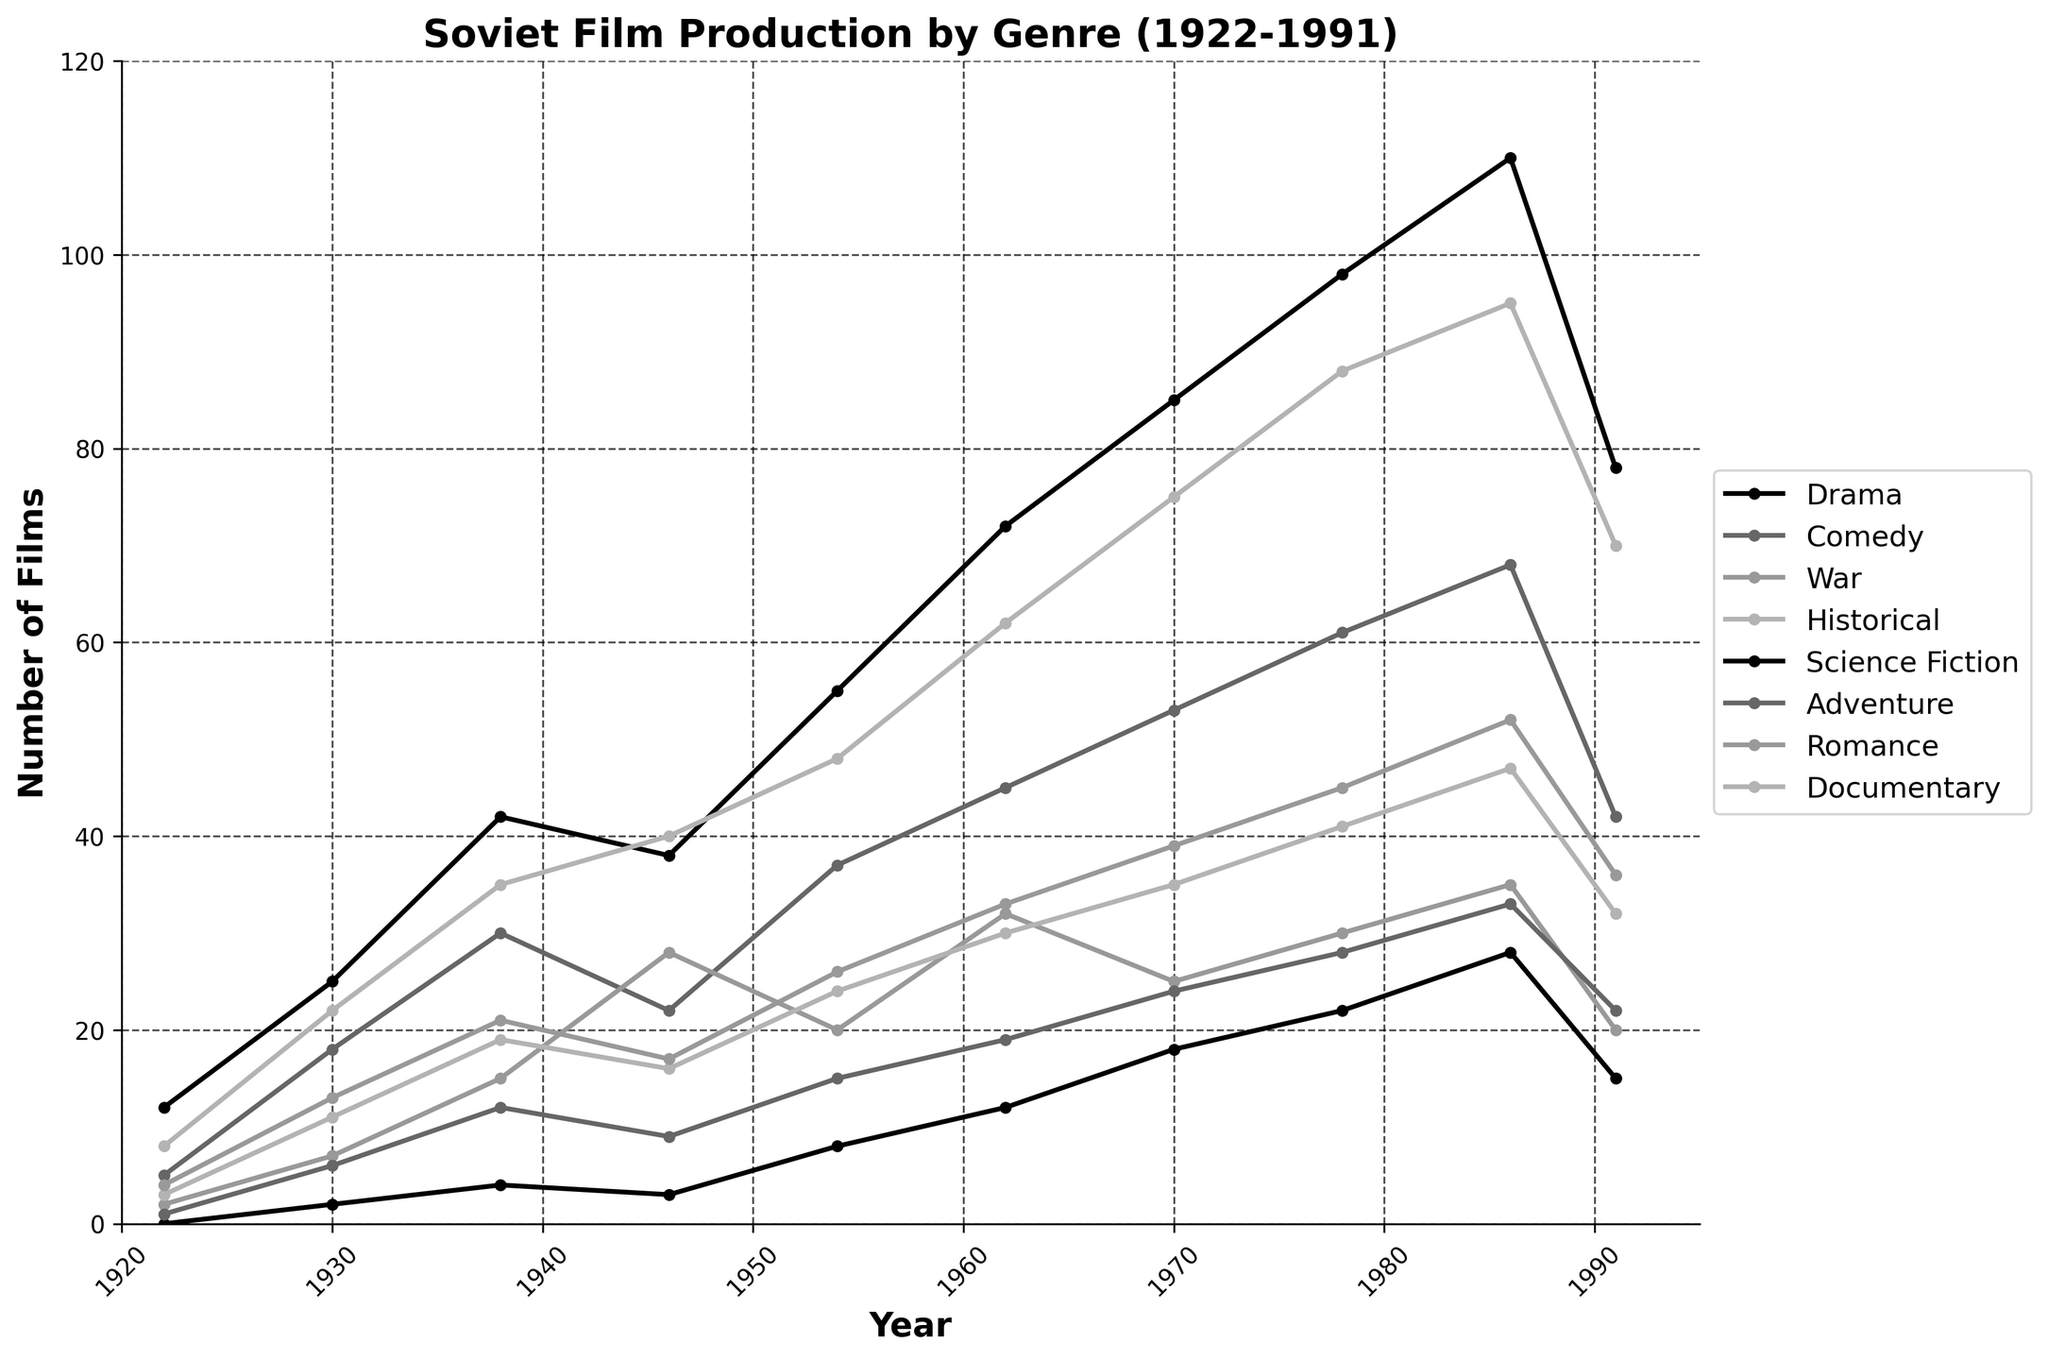Which genre saw the highest increase in the number of films produced from 1922 to 1991? To determine the genre with the highest increase, we need to find the difference in the number of films produced in 1991 and 1922 for each genre and identify the greatest difference.
Answer: Drama Which decade showed the most significant increase in the production of Documentary films? Examine the number of Documentary films produced in each decade and calculate the difference between the start and end of each decade to find the largest increase.
Answer: 1950s Is the number of Comedy films produced in 1938 greater than the number of Adventure films produced in 1978? Compare the number of Comedy films produced in 1938 (30) to the number of Adventure films produced in 1978 (28). Since 30 is greater than 28, the answer is yes.
Answer: Yes What is the average number of Science Fiction films produced per year across the reported years? Summing the number of Science Fiction films (0+2+4+3+8+12+18+22+28+15) gives 112 films over 10 years, thus the average is 112/10.
Answer: 11.2 In which year was the production of War films the highest? Look at the data for War films and identify the year with the highest count, which is 1946 with 28 films.
Answer: 1946 How does the number of Historical films produced in 1986 compare to 1970? The number of Historical films in 1986 is 47, and in 1970 is 35. Since 47 is greater than 35, production increased.
Answer: Increased Between which consecutive reporting years did Romance films production increase the most? Calculate the difference in the number of Romance films between each consecutive reporting year and identify the largest increase, which occurs between 1930 and 1938.
Answer: 1930 to 1938 What is the sum of Drama and Comedy films produced in 1962? Add the number of Drama films (72) to the number of Comedy films (45) for 1962.
Answer: 117 Which year had the lowest combined production of War and Science Fiction films? Sum the number of War and Science Fiction films for each year and identify the lowest sum, which occurs in 1922.
Answer: 1922 